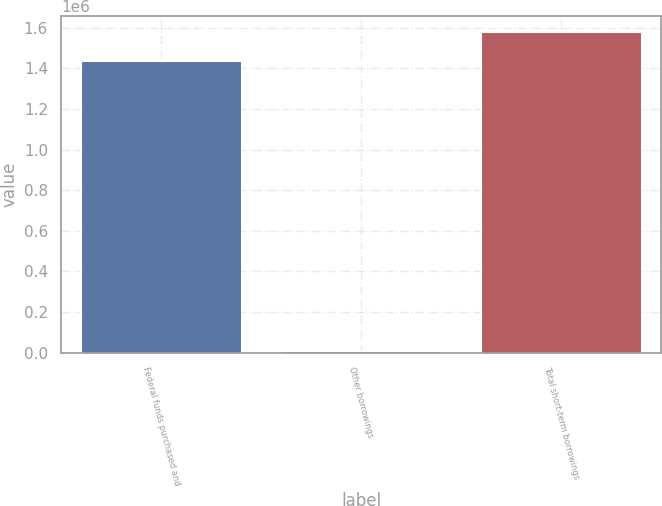<chart> <loc_0><loc_0><loc_500><loc_500><bar_chart><fcel>Federal funds purchased and<fcel>Other borrowings<fcel>Total short-term borrowings<nl><fcel>1.43431e+06<fcel>6782<fcel>1.57774e+06<nl></chart> 